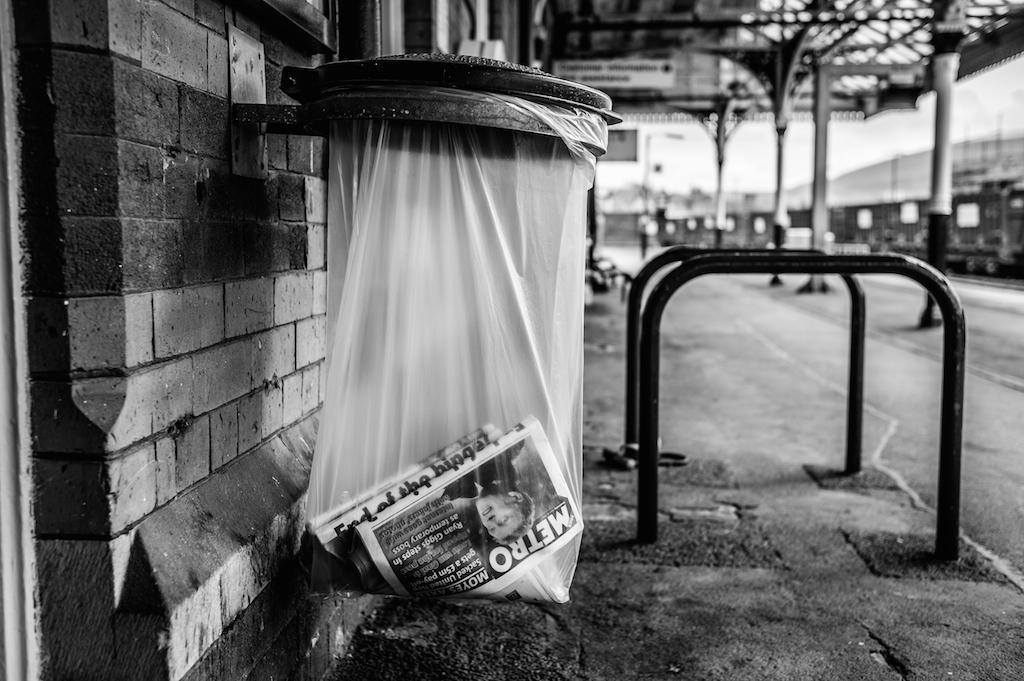<image>
Provide a brief description of the given image. A garbage can on the street with a Metro newspaper in it. 